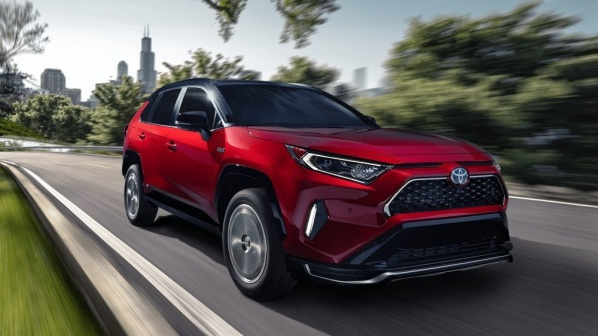Can you describe the main features of this image for me? The image presents a dynamic scene with a red Toyota RAV4 SUV as its central focus. The vehicle is in motion on a curving road, creating a sense of speed and direction. The SUV features a modern design with a black honeycomb grille, sleek LED headlights, and silver accents that highlight its vibrant red color.

The SUV's angled position suggests a turn, emphasizing its maneuverability and agility. In the blurred background, there is a city skyline with recognizable trees and buildings, providing an urban context for the scene. This depth of field effect makes the car stand out sharply against the slightly out-of-focus cityscape. The image is vivid and rich in detail, giving a realistic impression of the setting. 